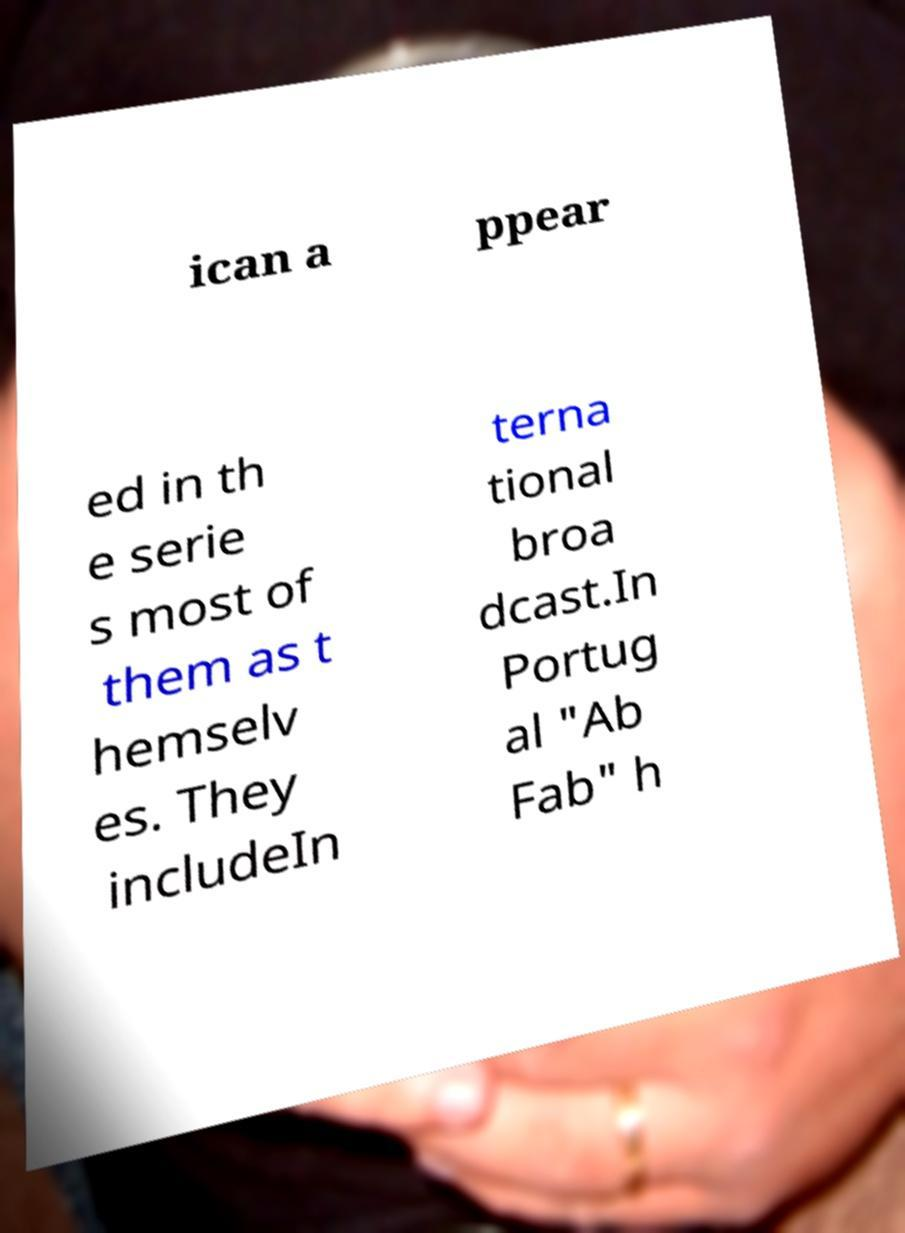Could you assist in decoding the text presented in this image and type it out clearly? ican a ppear ed in th e serie s most of them as t hemselv es. They includeIn terna tional broa dcast.In Portug al "Ab Fab" h 